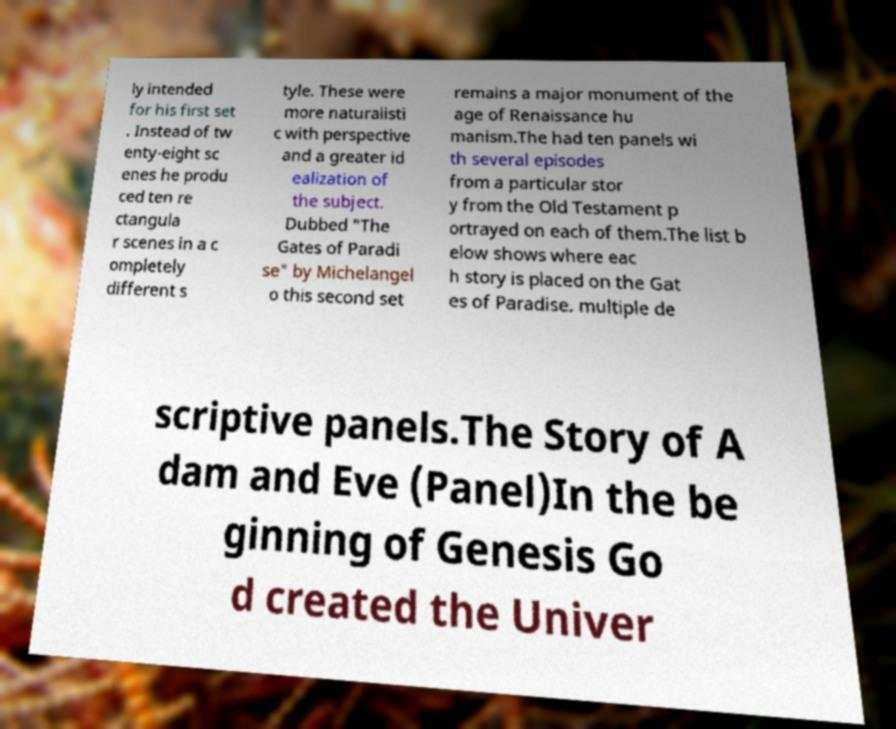Please read and relay the text visible in this image. What does it say? ly intended for his first set . Instead of tw enty-eight sc enes he produ ced ten re ctangula r scenes in a c ompletely different s tyle. These were more naturalisti c with perspective and a greater id ealization of the subject. Dubbed "The Gates of Paradi se" by Michelangel o this second set remains a major monument of the age of Renaissance hu manism.The had ten panels wi th several episodes from a particular stor y from the Old Testament p ortrayed on each of them.The list b elow shows where eac h story is placed on the Gat es of Paradise. multiple de scriptive panels.The Story of A dam and Eve (Panel)In the be ginning of Genesis Go d created the Univer 